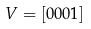Convert formula to latex. <formula><loc_0><loc_0><loc_500><loc_500>V = [ 0 0 0 1 ]</formula> 